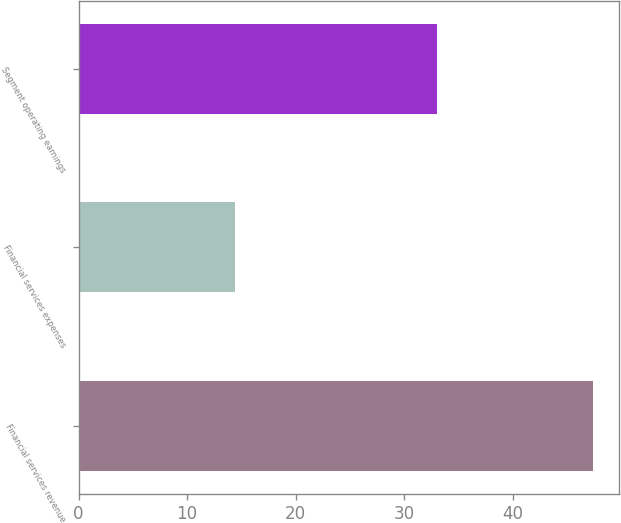Convert chart to OTSL. <chart><loc_0><loc_0><loc_500><loc_500><bar_chart><fcel>Financial services revenue<fcel>Financial services expenses<fcel>Segment operating earnings<nl><fcel>47.4<fcel>14.4<fcel>33<nl></chart> 